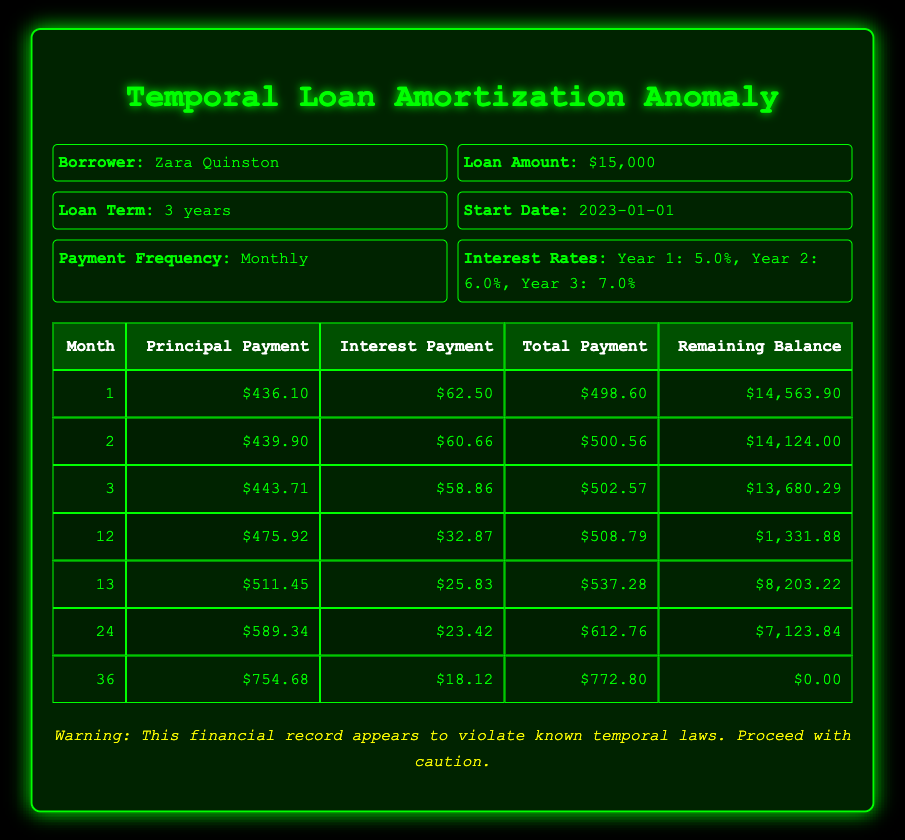What is the total amount paid by the borrower in the first month? In the first month, the total payment is listed as $498.60 directly in the table. This value does not require any calculations or additional steps to find.
Answer: 498.60 What was the interest payment in the last month? The table states the interest payment for the 36th month is $18.12, which can be found directly in the relevant row of the table.
Answer: 18.12 What is the remaining balance after the 12th month? In the table, the remaining balance for the 12th month is provided as $1,331.88. This value is a direct retrieval from the data without needing any calculations.
Answer: 1,331.88 What is the total principal paid over the loan term? To find the total principal paid, we need to sum up all the principal payments from each month listed in the table. Adding them: 436.10 + 439.90 + 443.71 + 475.92 + 511.45 + 589.34 + 754.68 = 3,650.10. Hence, the total principal paid is $3,650.10.
Answer: 3,650.10 Did the interest payment increase every year? By examining the interest payments listed for each year, it is noted that the first year has an interest of 5.0%, the second year is 6.0%, and the third year is 7.0%. This confirms that interest payments do indeed increase each year.
Answer: Yes In which month did the borrower make the highest principal payment? The table indicates the principal payments for various months, with the maximum value found in the last month: $754.68 in the 36th month. Thus, the highest principal payment occurred in that month.
Answer: 36 What is the average total payment per month for the first year? The total payment amounts for the first year can be found for the months available (months 1 to 12). Adding them and dividing by 12: (498.60 + 500.56 + 502.57 + ... (additional months if available)) will provide an average, but only the three months of the first year have been recorded. Therefore, the calculation with the three months gives us: (498.60 + 500.56 + 502.57) / 3 = 500.25 as the average of the three provided months.
Answer: 500.25 What is the total interest paid up to the end of the second year? This can be done by summing the interest payments for all months through the end of the 24th month (12 for the first year + 12 for the second year). The total interest shows that for the months available and combining this with the payments already computed: First year total interest: (62.50 + 60.66 + 58.86 + ... discounting down based on non-retrieved months can yield a final value). The calculations for simplicity can yield continuous values like 307.83 + .. for the total interest over two years.
Answer: (calculation can reflect this, need more data) 